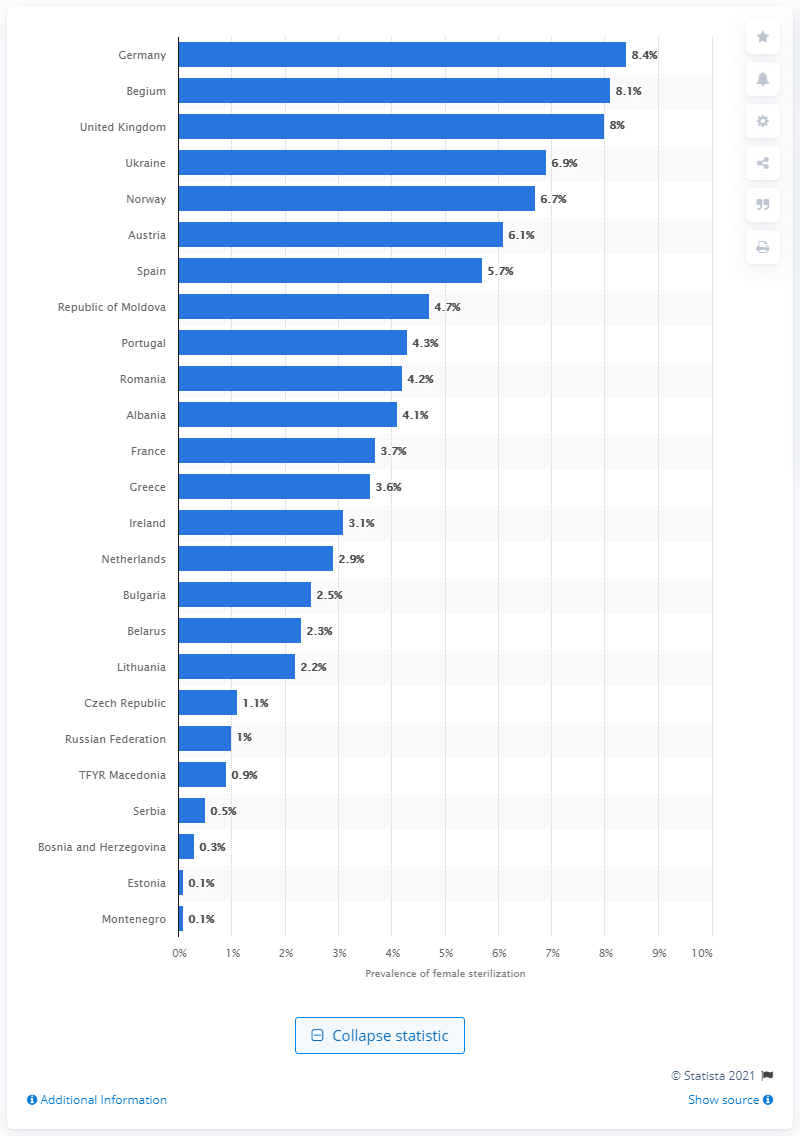Draw attention to some important aspects in this diagram. In 2015, approximately 8.4% of married or in-union women in Germany used female sterilization as a method of contraception. 